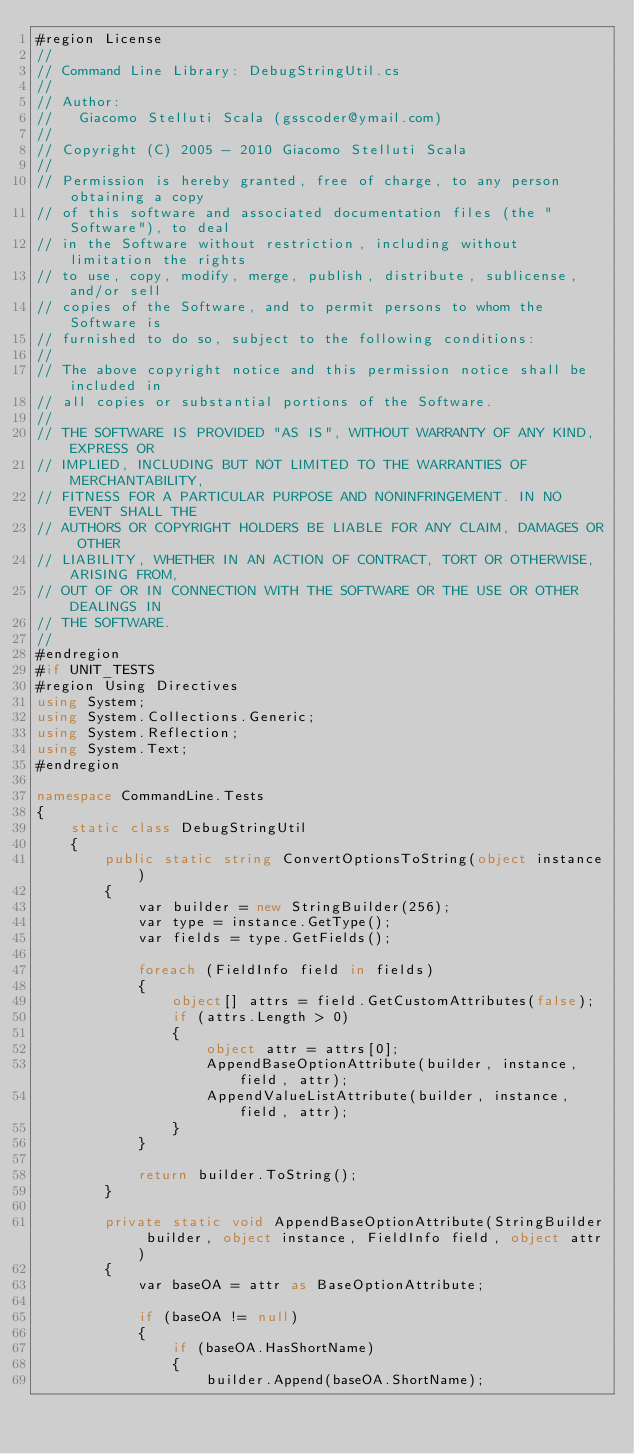<code> <loc_0><loc_0><loc_500><loc_500><_C#_>#region License
//
// Command Line Library: DebugStringUtil.cs
//
// Author:
//   Giacomo Stelluti Scala (gsscoder@ymail.com)
//
// Copyright (C) 2005 - 2010 Giacomo Stelluti Scala
//
// Permission is hereby granted, free of charge, to any person obtaining a copy
// of this software and associated documentation files (the "Software"), to deal
// in the Software without restriction, including without limitation the rights
// to use, copy, modify, merge, publish, distribute, sublicense, and/or sell
// copies of the Software, and to permit persons to whom the Software is
// furnished to do so, subject to the following conditions:
//
// The above copyright notice and this permission notice shall be included in
// all copies or substantial portions of the Software.
//
// THE SOFTWARE IS PROVIDED "AS IS", WITHOUT WARRANTY OF ANY KIND, EXPRESS OR
// IMPLIED, INCLUDING BUT NOT LIMITED TO THE WARRANTIES OF MERCHANTABILITY,
// FITNESS FOR A PARTICULAR PURPOSE AND NONINFRINGEMENT. IN NO EVENT SHALL THE
// AUTHORS OR COPYRIGHT HOLDERS BE LIABLE FOR ANY CLAIM, DAMAGES OR OTHER
// LIABILITY, WHETHER IN AN ACTION OF CONTRACT, TORT OR OTHERWISE, ARISING FROM,
// OUT OF OR IN CONNECTION WITH THE SOFTWARE OR THE USE OR OTHER DEALINGS IN
// THE SOFTWARE.
//
#endregion
#if UNIT_TESTS
#region Using Directives
using System;
using System.Collections.Generic;
using System.Reflection;
using System.Text;
#endregion

namespace CommandLine.Tests
{
    static class DebugStringUtil
    {
        public static string ConvertOptionsToString(object instance)
        {
            var builder = new StringBuilder(256);
            var type = instance.GetType();
            var fields = type.GetFields();            

            foreach (FieldInfo field in fields)
            {
                object[] attrs = field.GetCustomAttributes(false);
                if (attrs.Length > 0)
                {
                    object attr = attrs[0];
                    AppendBaseOptionAttribute(builder, instance, field, attr);
                    AppendValueListAttribute(builder, instance, field, attr);
                }
            }

            return builder.ToString();
        }

        private static void AppendBaseOptionAttribute(StringBuilder builder, object instance, FieldInfo field, object attr)
        {
            var baseOA = attr as BaseOptionAttribute;

            if (baseOA != null)
            {
                if (baseOA.HasShortName)
                {
                    builder.Append(baseOA.ShortName);</code> 